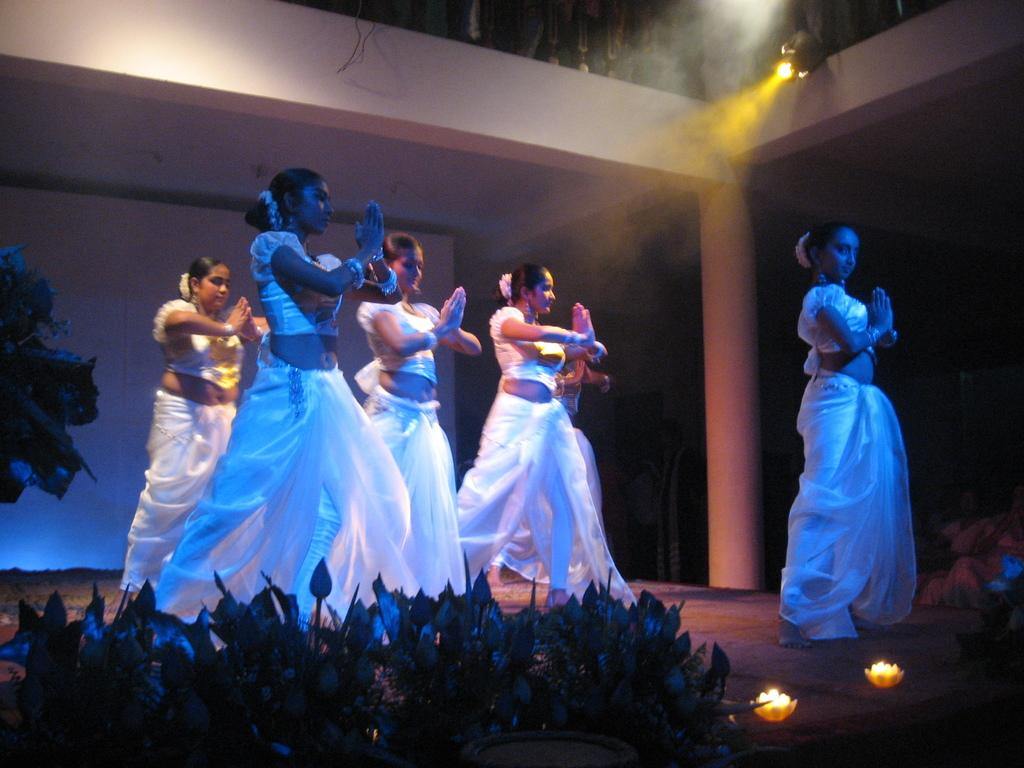What are the people in the image doing? There is a group of people dancing in the image. What is the setting for the dancing? There is a stage in the image. What is placed in front of the stage? There is a group of plants placed in front of the stage. Who else is present in the image besides the dancers? There is a group of people watching the dancing ladies in the image. Can you tell me where the zoo is located in the image? There is no zoo present in the image; it features a group of people dancing on a stage. What type of vacation is the mom planning in the image? There is no mom or vacation mentioned in the image; it focuses on a group of people dancing on a stage. 